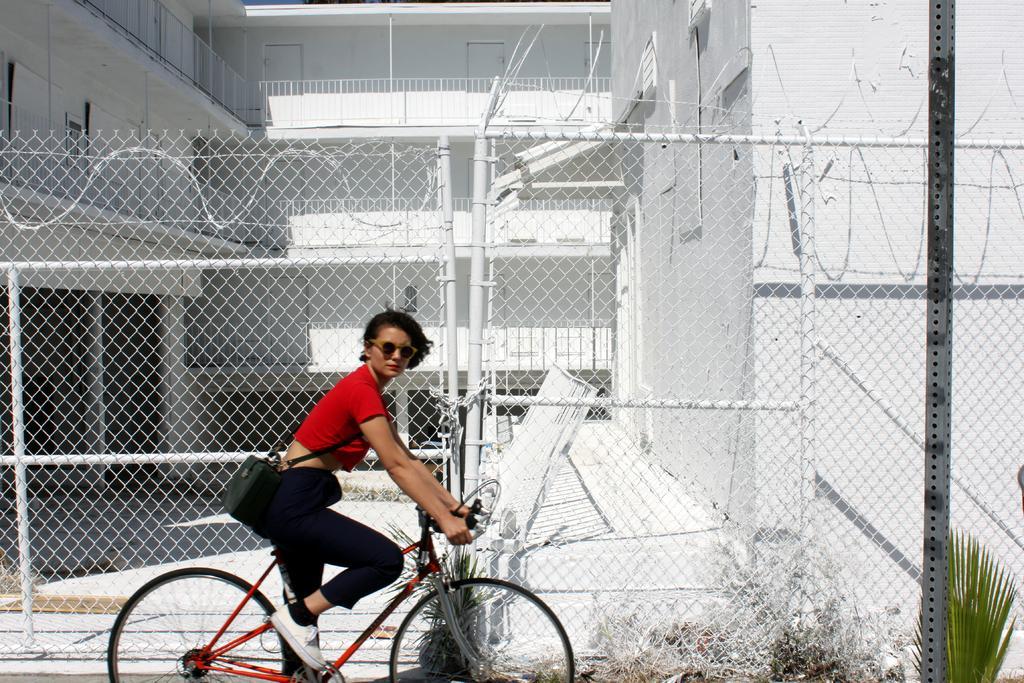How would you summarize this image in a sentence or two? This is a picture were taken in the outdoor, the women is riding the bicycle the women is in red t shirt and black pant. Background of the women there is a white color fencing and the white color building. 